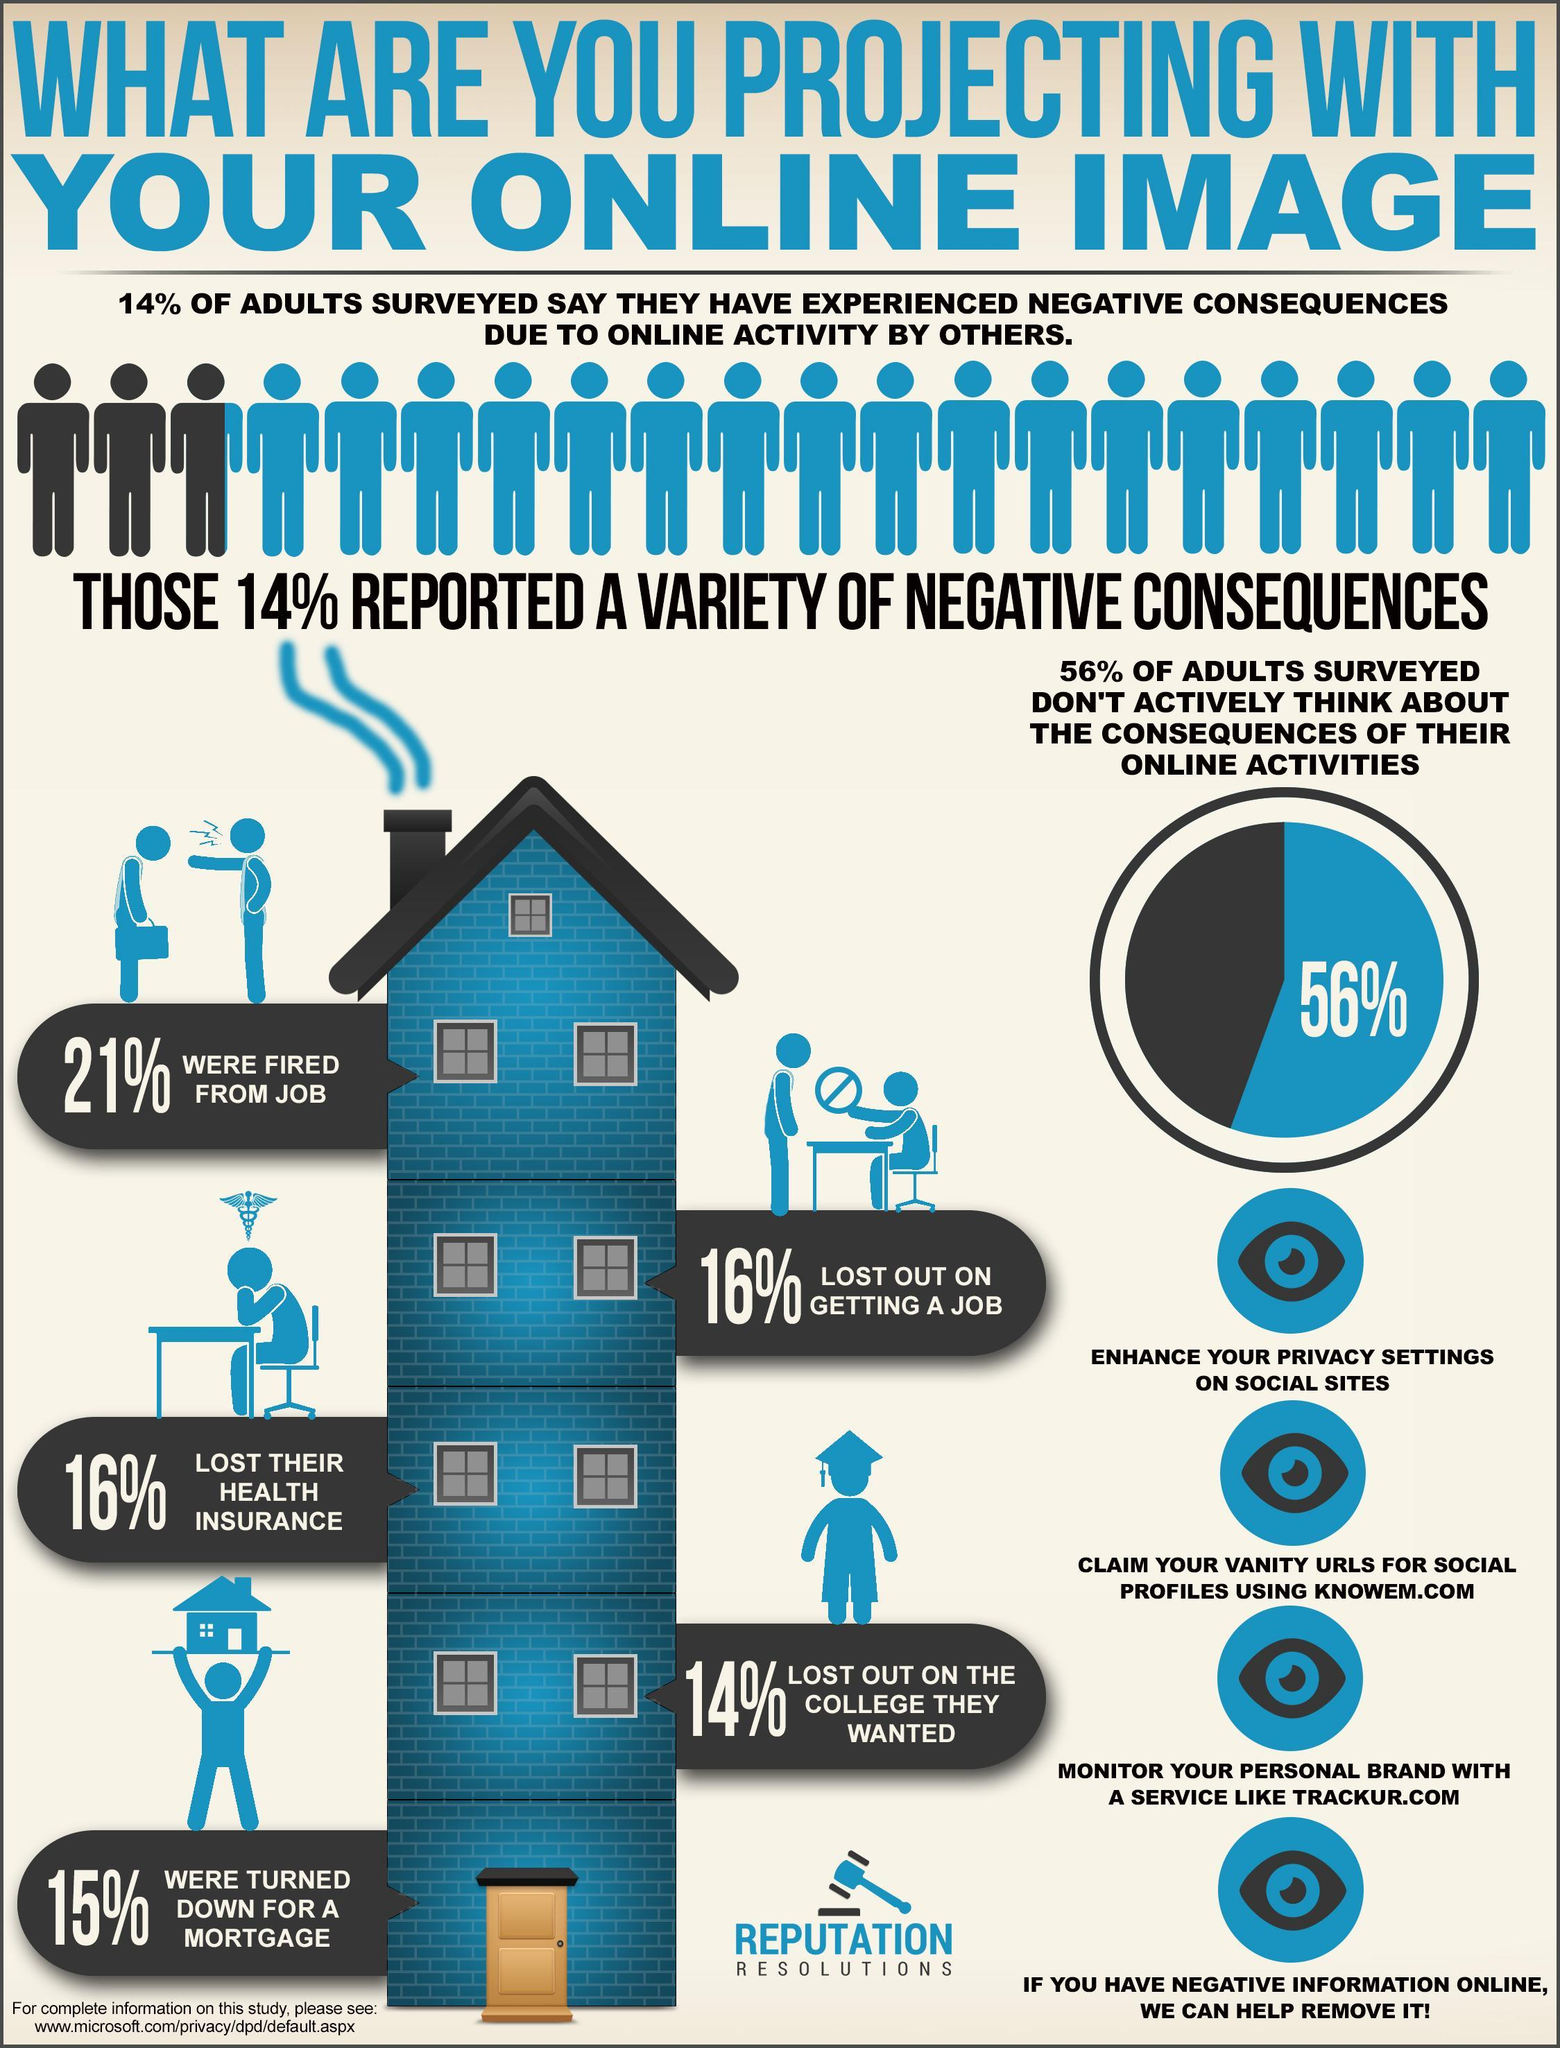What percent of adults have not faced negative consequences due to online activity by others?
Answer the question with a short phrase. 86% What percent of adults actively think about the consequences of their online activities? 44% 